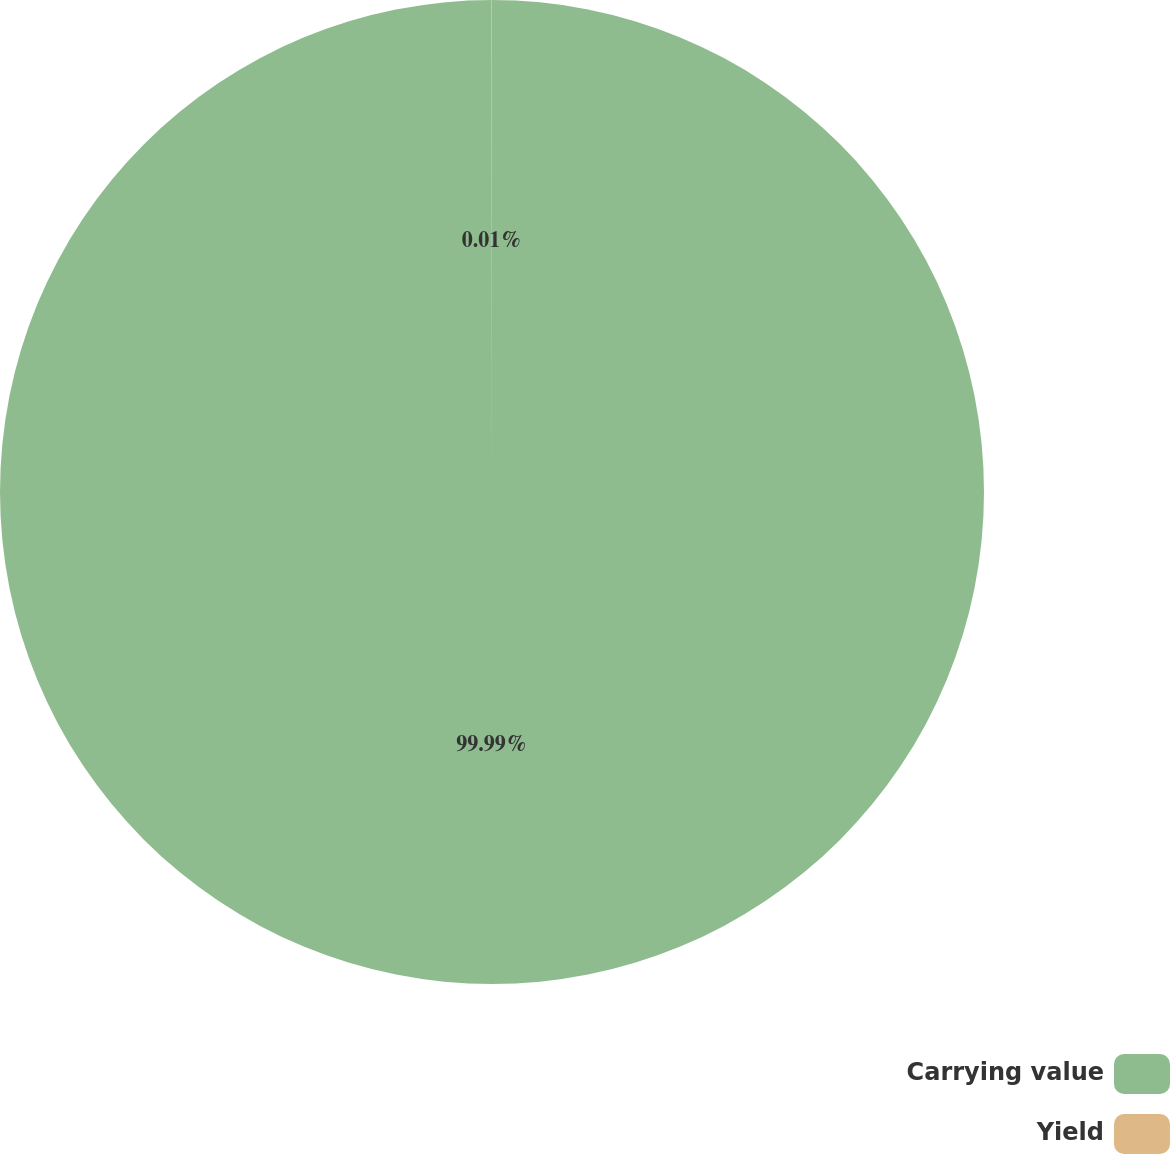<chart> <loc_0><loc_0><loc_500><loc_500><pie_chart><fcel>Carrying value<fcel>Yield<nl><fcel>99.99%<fcel>0.01%<nl></chart> 